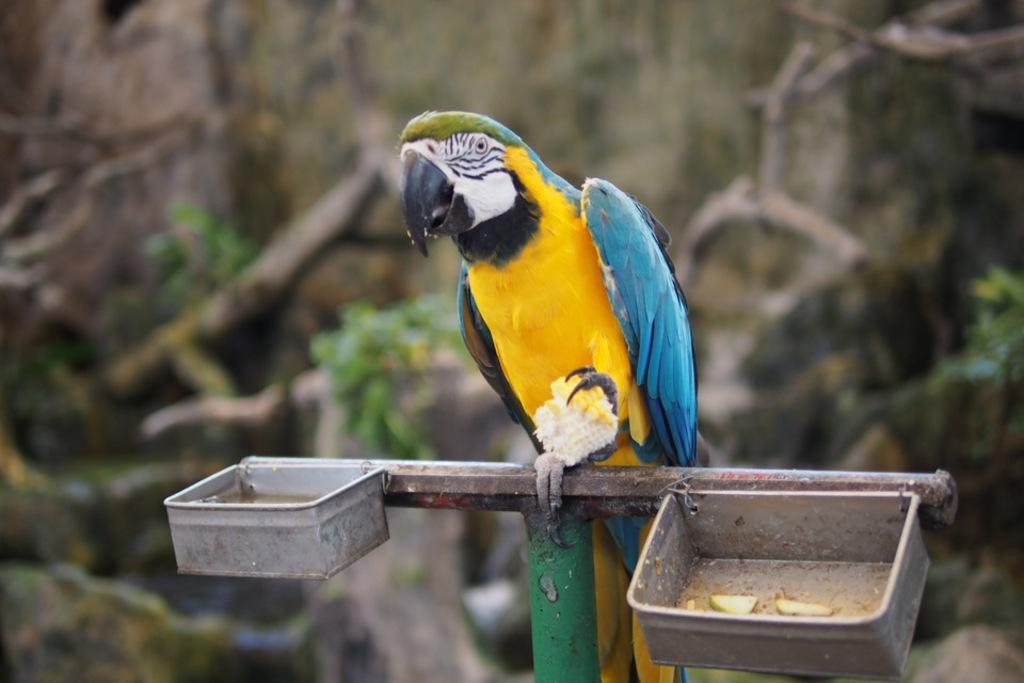What type of animal is in the image? There is a parrot in the image. What objects can be seen besides the parrot? There are two small tin boxes in the image. Can you describe the background of the image? The background of the image is blurred. What type of blade is being used to apply toothpaste in the image? There is no blade or toothpaste present in the image. 